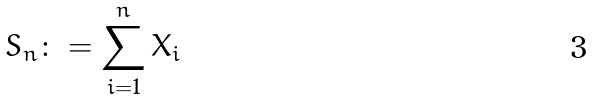<formula> <loc_0><loc_0><loc_500><loc_500>S _ { n } \colon = \sum _ { i = 1 } ^ { n } X _ { i }</formula> 